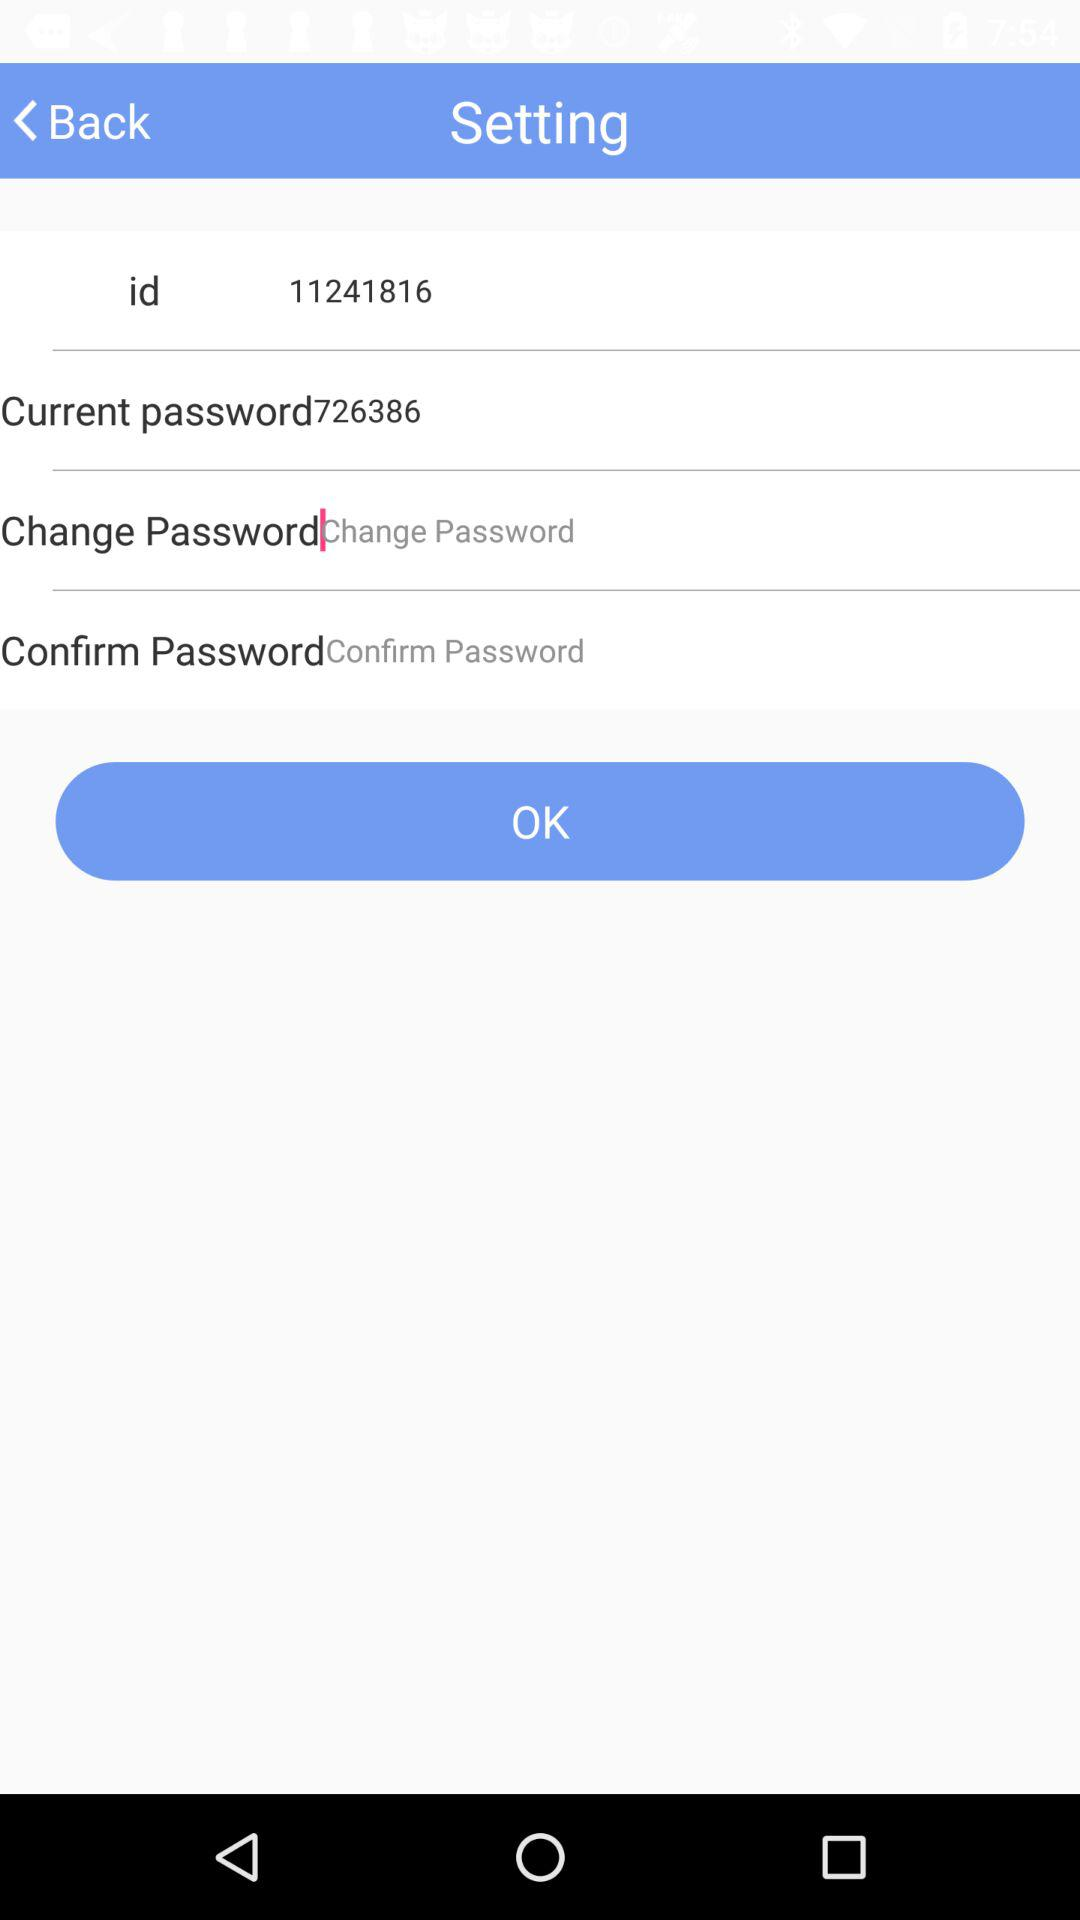What is the ID? The ID is 11241816. 